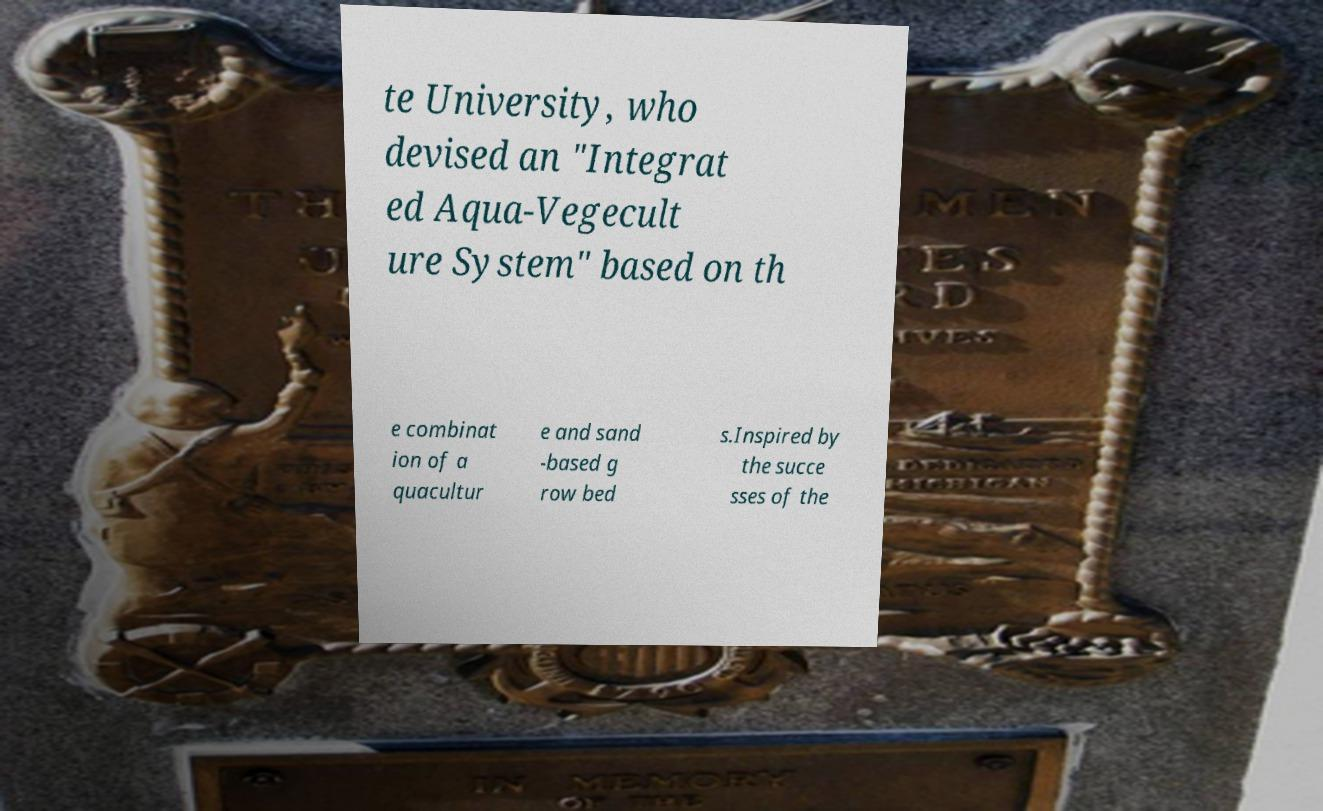Can you accurately transcribe the text from the provided image for me? te University, who devised an "Integrat ed Aqua-Vegecult ure System" based on th e combinat ion of a quacultur e and sand -based g row bed s.Inspired by the succe sses of the 